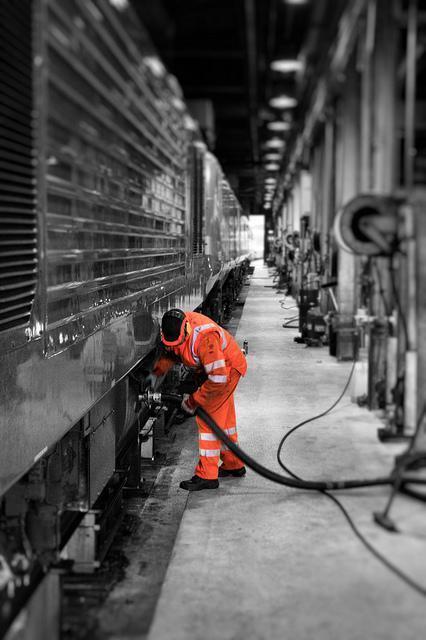How many beer bottles have a yellow label on them?
Give a very brief answer. 0. 